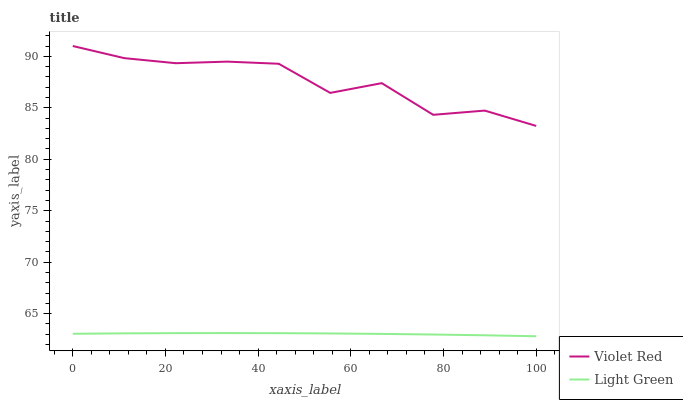Does Light Green have the minimum area under the curve?
Answer yes or no. Yes. Does Violet Red have the maximum area under the curve?
Answer yes or no. Yes. Does Light Green have the maximum area under the curve?
Answer yes or no. No. Is Light Green the smoothest?
Answer yes or no. Yes. Is Violet Red the roughest?
Answer yes or no. Yes. Is Light Green the roughest?
Answer yes or no. No. Does Light Green have the lowest value?
Answer yes or no. Yes. Does Violet Red have the highest value?
Answer yes or no. Yes. Does Light Green have the highest value?
Answer yes or no. No. Is Light Green less than Violet Red?
Answer yes or no. Yes. Is Violet Red greater than Light Green?
Answer yes or no. Yes. Does Light Green intersect Violet Red?
Answer yes or no. No. 